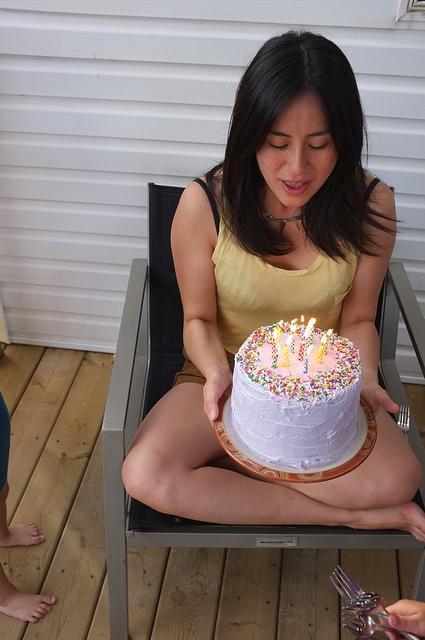How many chairs are in the photo?
Give a very brief answer. 1. How many people are in the photo?
Give a very brief answer. 2. 